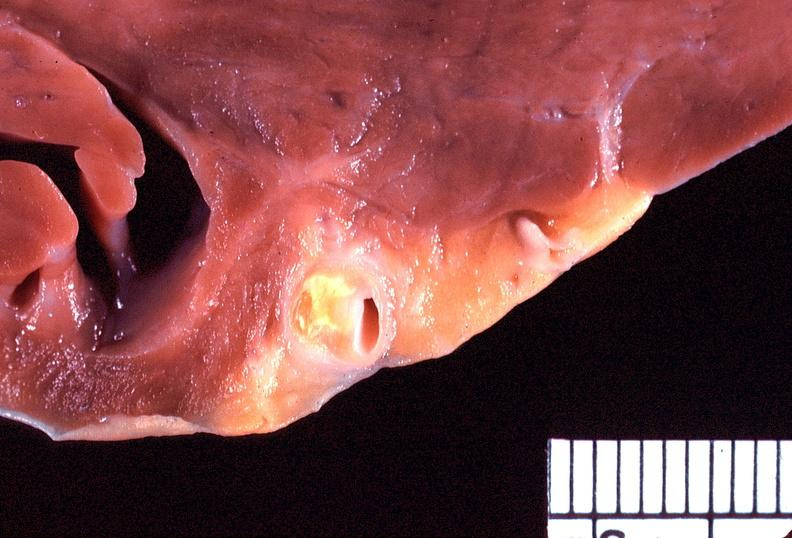s adenocarcinoma present?
Answer the question using a single word or phrase. No 